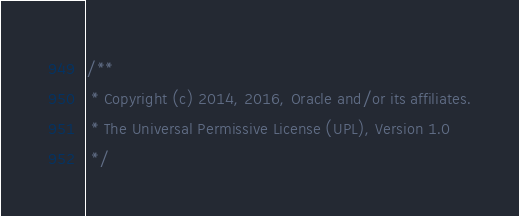Convert code to text. <code><loc_0><loc_0><loc_500><loc_500><_JavaScript_>/**
 * Copyright (c) 2014, 2016, Oracle and/or its affiliates.
 * The Universal Permissive License (UPL), Version 1.0
 */</code> 